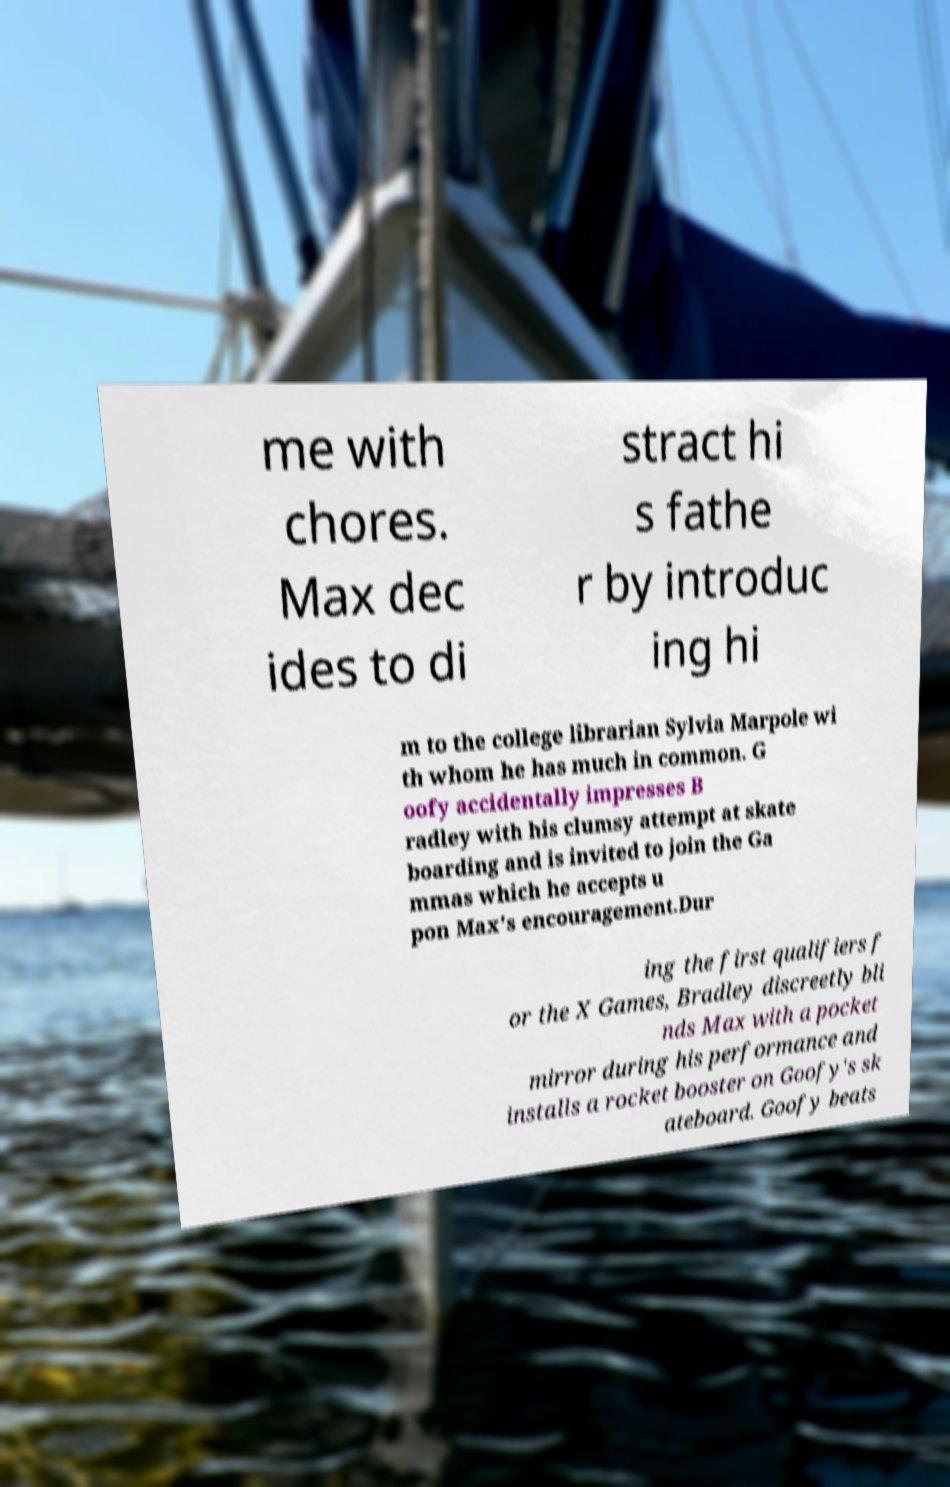For documentation purposes, I need the text within this image transcribed. Could you provide that? me with chores. Max dec ides to di stract hi s fathe r by introduc ing hi m to the college librarian Sylvia Marpole wi th whom he has much in common. G oofy accidentally impresses B radley with his clumsy attempt at skate boarding and is invited to join the Ga mmas which he accepts u pon Max's encouragement.Dur ing the first qualifiers f or the X Games, Bradley discreetly bli nds Max with a pocket mirror during his performance and installs a rocket booster on Goofy's sk ateboard. Goofy beats 